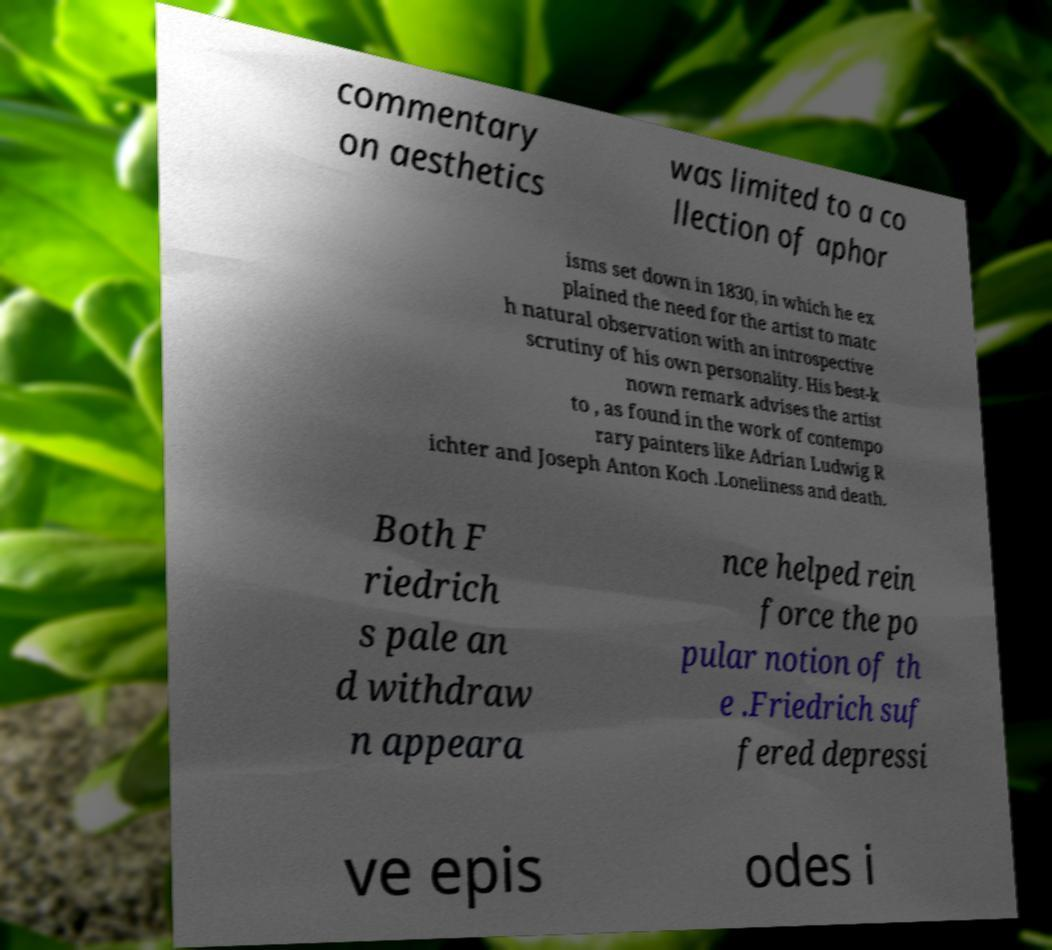Please identify and transcribe the text found in this image. commentary on aesthetics was limited to a co llection of aphor isms set down in 1830, in which he ex plained the need for the artist to matc h natural observation with an introspective scrutiny of his own personality. His best-k nown remark advises the artist to , as found in the work of contempo rary painters like Adrian Ludwig R ichter and Joseph Anton Koch .Loneliness and death. Both F riedrich s pale an d withdraw n appeara nce helped rein force the po pular notion of th e .Friedrich suf fered depressi ve epis odes i 